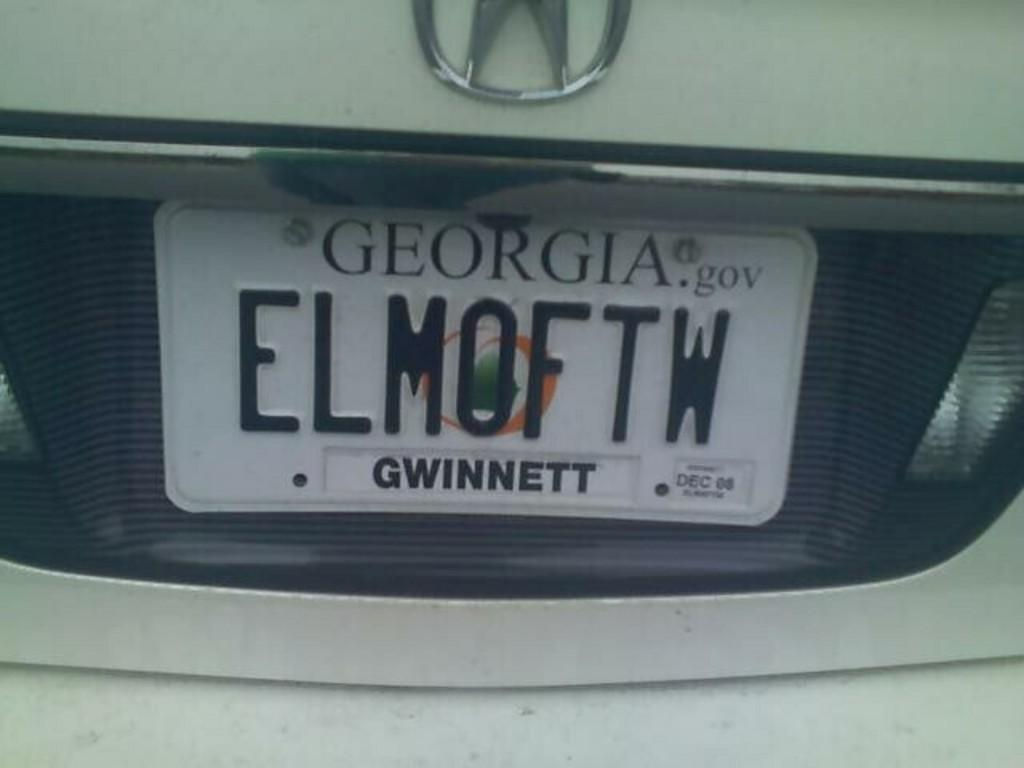<image>
Describe the image concisely. A Georgia licence plate for the Gwinnett county. 